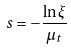Convert formula to latex. <formula><loc_0><loc_0><loc_500><loc_500>s = - \frac { \ln \xi } { \mu _ { t } }</formula> 